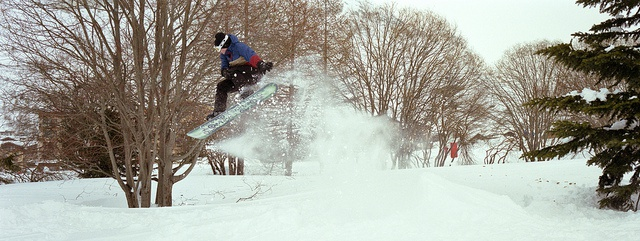Describe the objects in this image and their specific colors. I can see people in darkgray, black, gray, navy, and maroon tones and snowboard in darkgray, beige, lightgray, and gray tones in this image. 